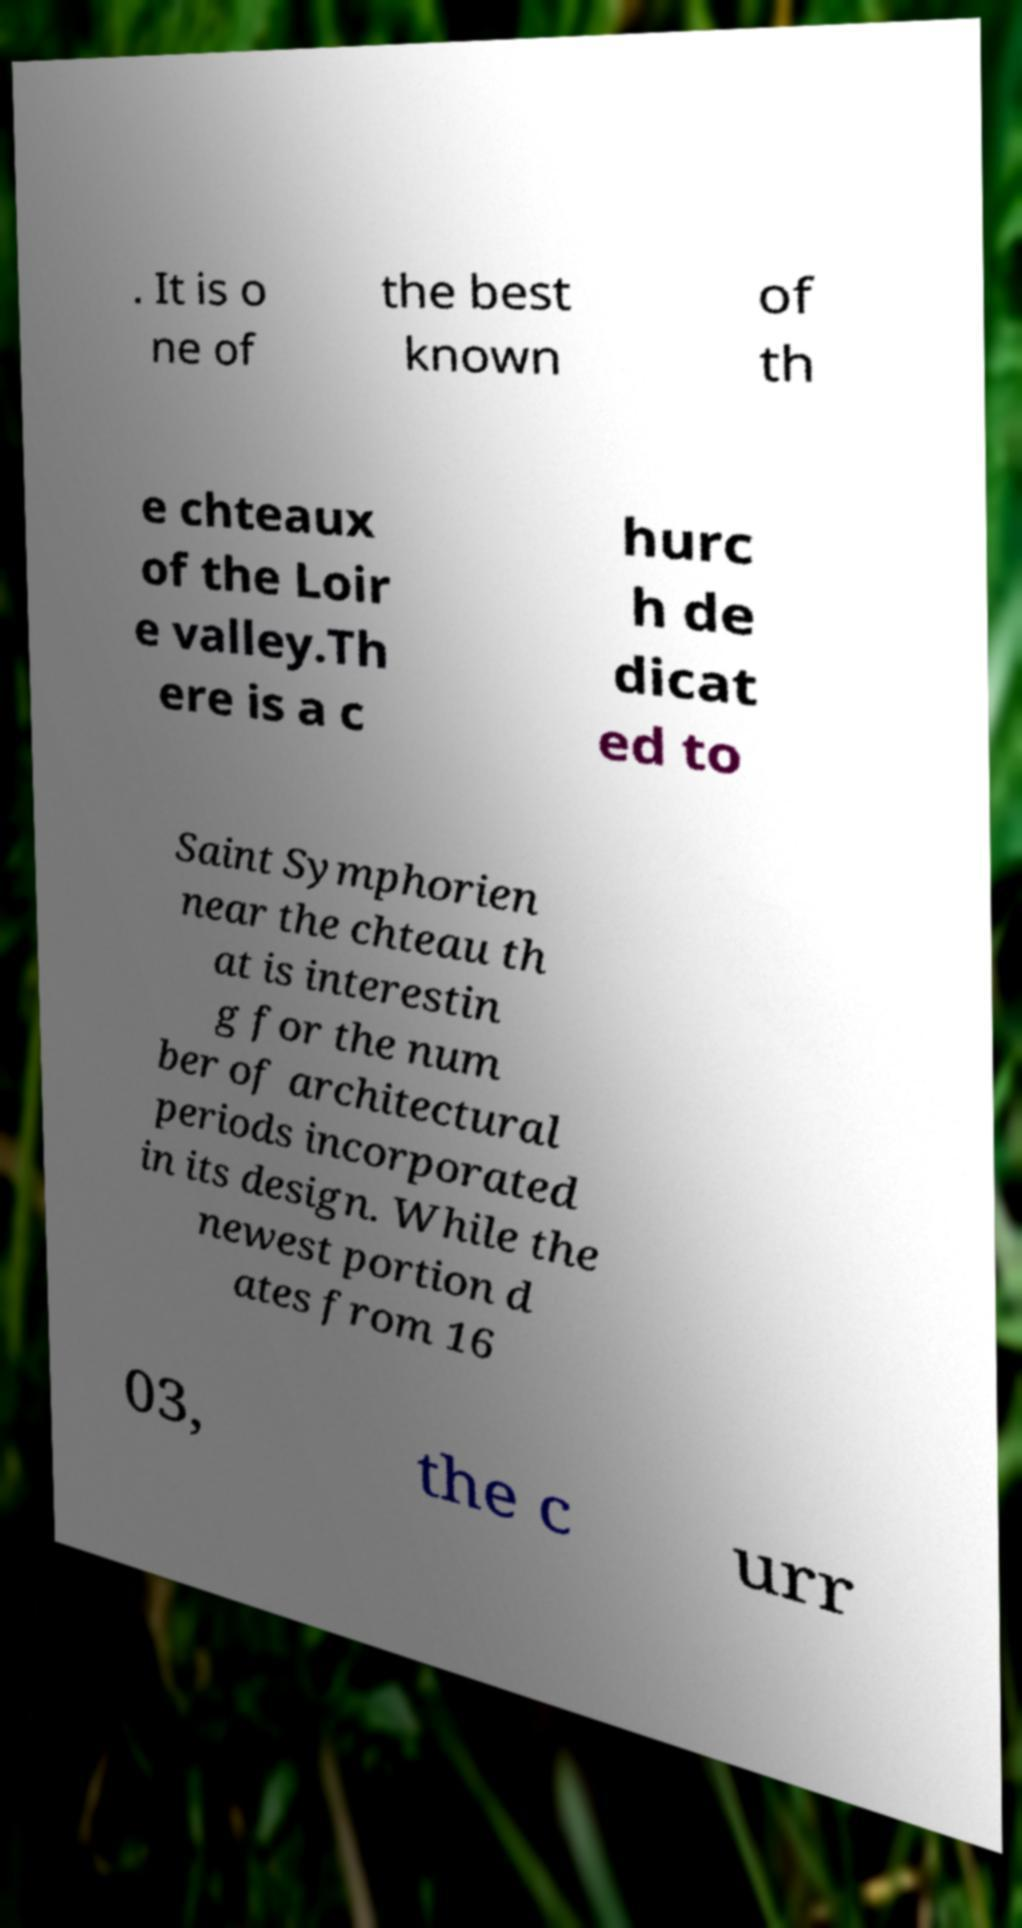For documentation purposes, I need the text within this image transcribed. Could you provide that? . It is o ne of the best known of th e chteaux of the Loir e valley.Th ere is a c hurc h de dicat ed to Saint Symphorien near the chteau th at is interestin g for the num ber of architectural periods incorporated in its design. While the newest portion d ates from 16 03, the c urr 